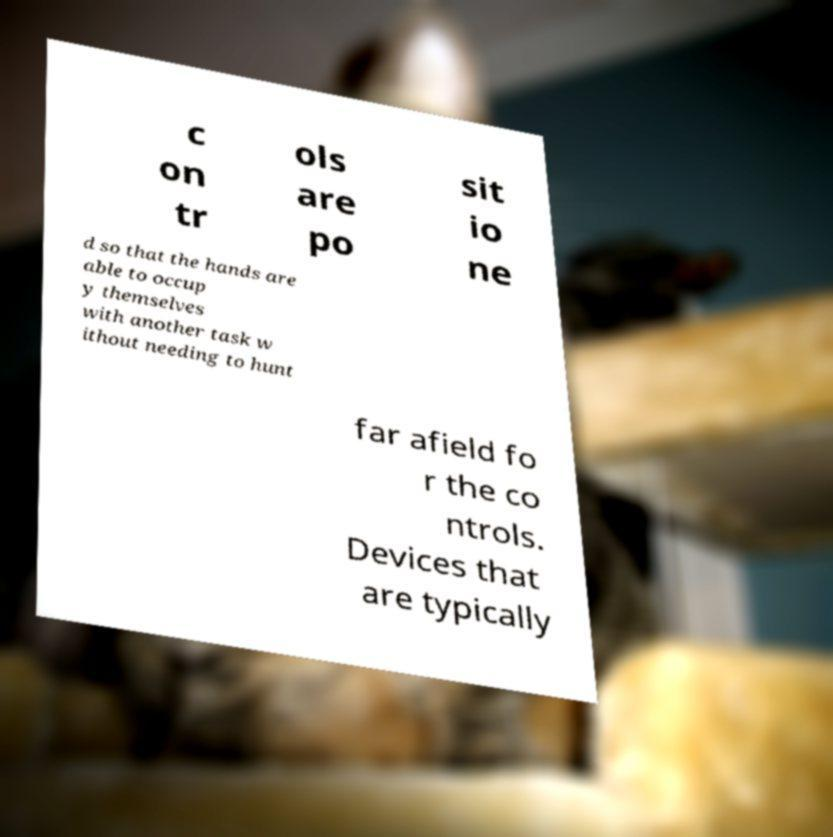There's text embedded in this image that I need extracted. Can you transcribe it verbatim? c on tr ols are po sit io ne d so that the hands are able to occup y themselves with another task w ithout needing to hunt far afield fo r the co ntrols. Devices that are typically 